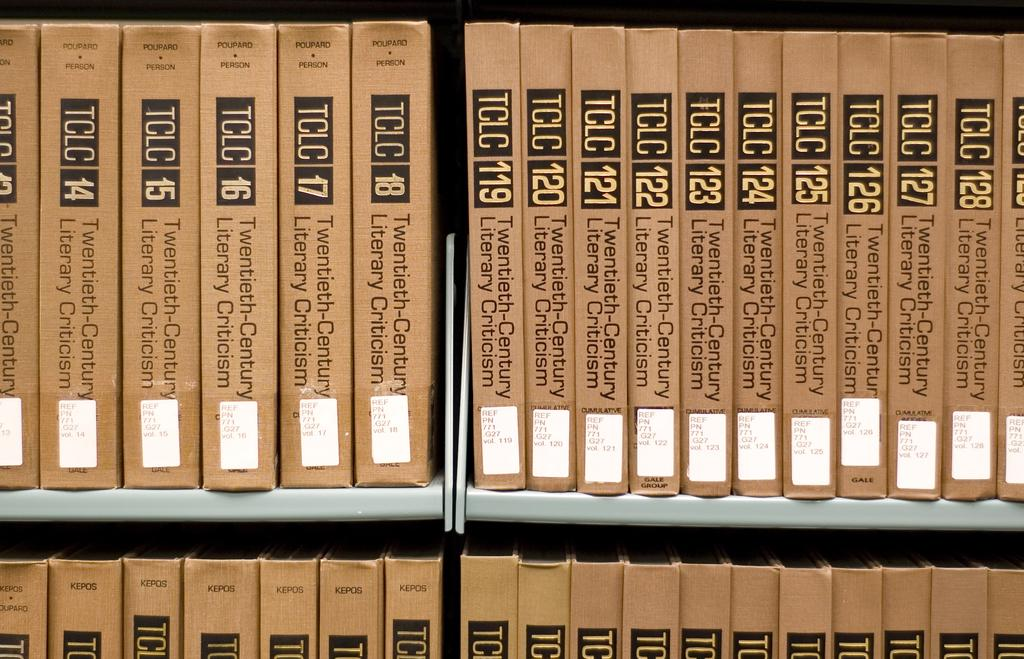What objects are visible in the image? There are books in the image. How are the books arranged in the image? The books are present in racks. What type of texture can be felt on the books in the image? The image does not provide information about the texture of the books, so it cannot be determined from the image. 